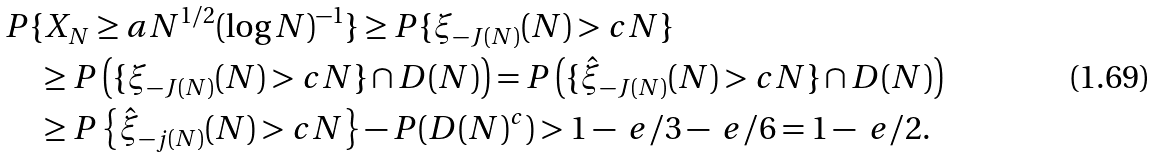<formula> <loc_0><loc_0><loc_500><loc_500>& P \{ X _ { N } \geq a N ^ { 1 / 2 } ( \log N ) ^ { - 1 } \} \geq P \{ \xi _ { - J ( N ) } ( N ) > c N \} \\ & \quad \geq P \left ( \{ \xi _ { - J ( N ) } ( N ) > c N \} \cap D ( N ) \right ) = P \left ( \{ \hat { \xi } _ { - J ( N ) } ( N ) > c N \} \cap D ( N ) \right ) \\ & \quad \geq P \left \{ \hat { \xi } _ { - j ( N ) } ( N ) > c N \right \} - P ( D ( N ) ^ { c } ) > 1 - \ e / 3 - \ e / 6 = 1 - \ e / 2 .</formula> 